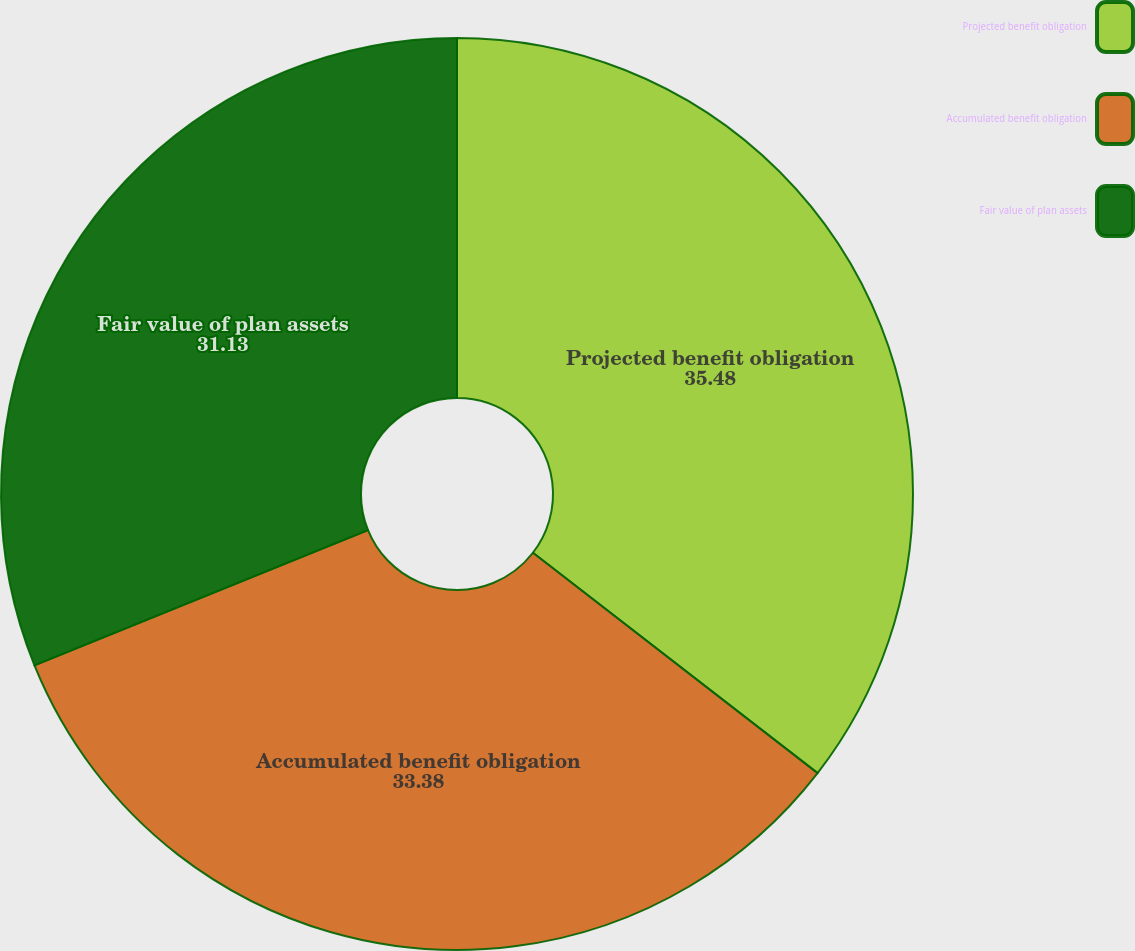<chart> <loc_0><loc_0><loc_500><loc_500><pie_chart><fcel>Projected benefit obligation<fcel>Accumulated benefit obligation<fcel>Fair value of plan assets<nl><fcel>35.48%<fcel>33.38%<fcel>31.13%<nl></chart> 